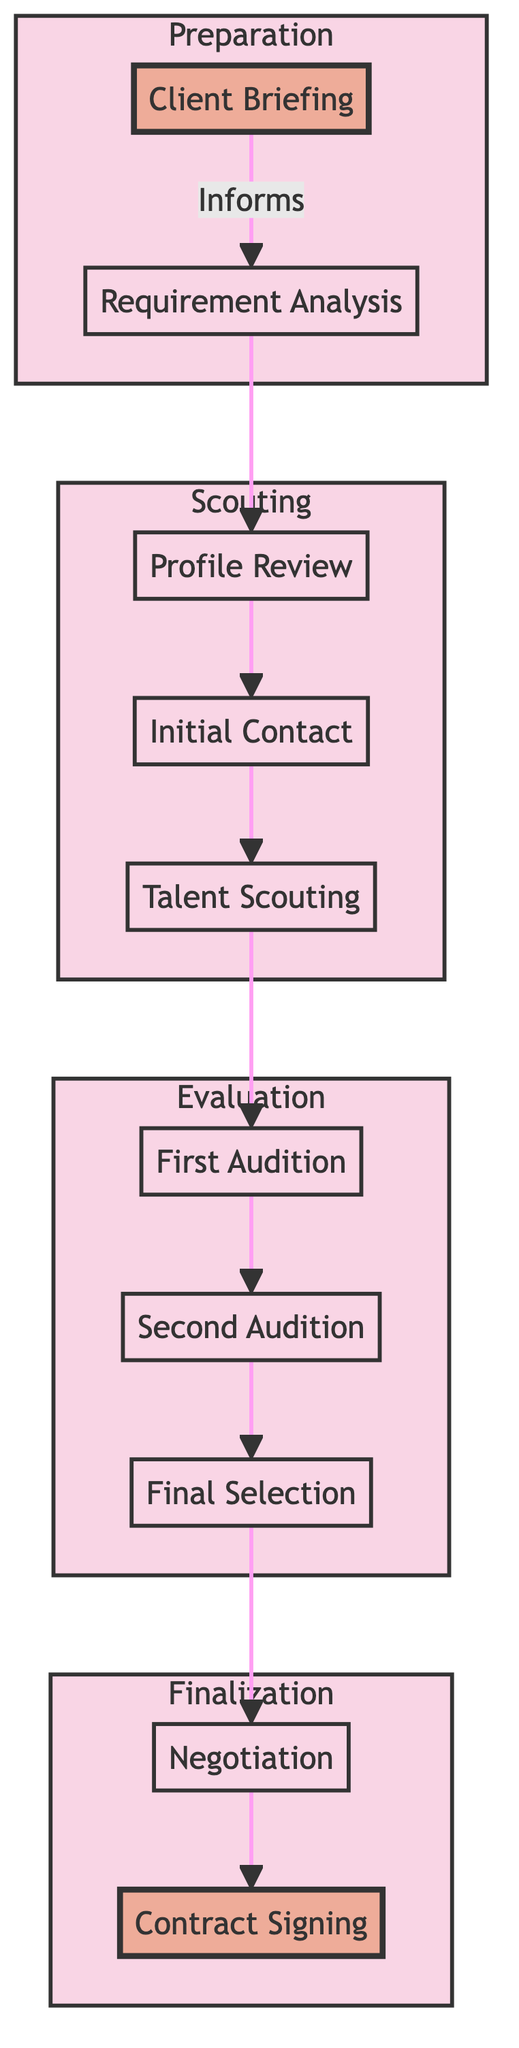What is the final step in the talent acquisition process? The diagram indicates that the final step, at the top of the flow, is "Contract Signing." This is derived from the flow of the process, which concludes with this node after all prior steps have been completed.
Answer: Contract Signing How many total steps are there in the talent acquisition process? By counting each distinct step in the diagram, there are ten nodes representing different stages in the acquisition process. This count includes steps such as "Client Briefing" and "Negotiation."
Answer: Ten What comes immediately after the "First Audition"? The diagram shows a direct flow indicating that the step following "First Audition" is "Second Audition." This can be assessed by looking at the arrows directing to and from the respective nodes.
Answer: Second Audition Which step involves understanding project requirements? The first step, "Client Briefing," directly relates to gathering an understanding of the project and role requirements, as indicated by the arrow directing from it to "Requirement Analysis."
Answer: Client Briefing What are the two nodes highlighted in the diagram? The diagram has highlighted "Client Briefing" at the start and "Contract Signing" at the end, which are the start and finish points of the talent acquisition process flow. These specific nodes are visually distinct due to the highlight styling applied.
Answer: Client Briefing, Contract Signing What role does "Negotiation" play in the process? "Negotiation" is the step that occurs after the "Final Selection" and before "Contract Signing," indicating that it is the phase in which terms and details are discussed. The process flow shows this direct connection post-selection and pre-contract.
Answer: Discusses terms Which subgraph represents the evaluation phase? The subgraph labeled "Evaluation" contains the nodes "First Audition," "Second Audition," and "Final Selection," indicating that these steps pertain to assessing the talent and making hiring decisions. The name of this subgraph categorically defines its role in the larger process.
Answer: Evaluation What is the purpose of "Profile Review"? "Profile Review" serves to assess resumes, portfolios, and applications, acting as a filter for further contact with potential talent. The previous step, "Requirement Analysis," establishes what criteria will be evaluated during this step.
Answer: Assess resumes How many subgraphs exist in the diagram? The diagram consists of four subgraphs: "Preparation," "Scouting," "Evaluation," and "Finalization." Each subgraph groups related steps based on their function in the overall process. Counting them directly from the visual sections will verify this.
Answer: Four What happens after "Talent Scouting"? The flow chart indicates that the next step following "Talent Scouting" is "First Audition," showing the sequential progression from identifying talent to evaluating their performance. This can be seen through the directional arrows flow in the diagram.
Answer: First Audition 